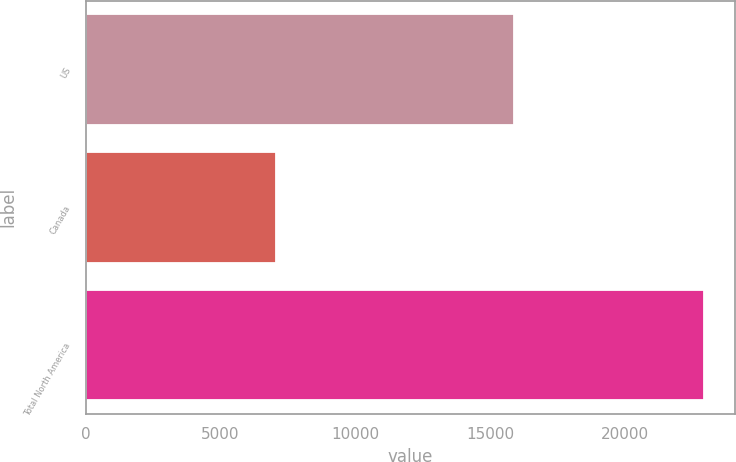Convert chart. <chart><loc_0><loc_0><loc_500><loc_500><bar_chart><fcel>US<fcel>Canada<fcel>Total North America<nl><fcel>15866<fcel>7056<fcel>22922<nl></chart> 